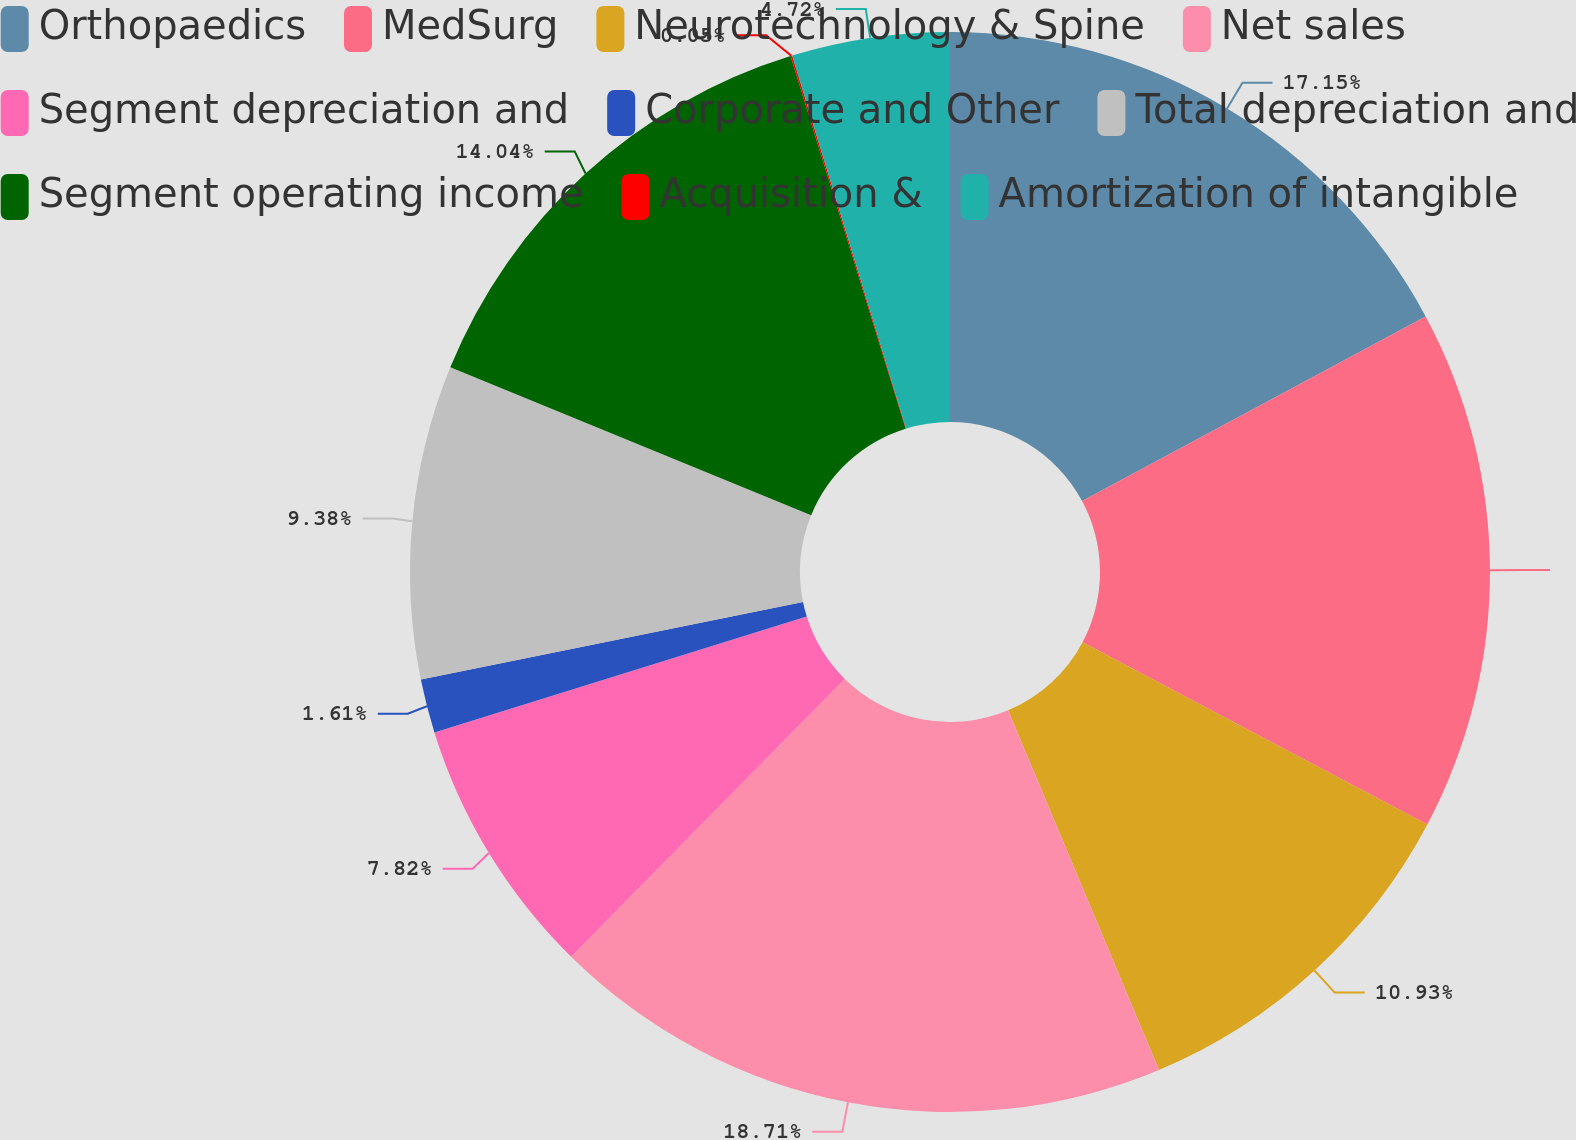Convert chart. <chart><loc_0><loc_0><loc_500><loc_500><pie_chart><fcel>Orthopaedics<fcel>MedSurg<fcel>Neurotechnology & Spine<fcel>Net sales<fcel>Segment depreciation and<fcel>Corporate and Other<fcel>Total depreciation and<fcel>Segment operating income<fcel>Acquisition &<fcel>Amortization of intangible<nl><fcel>17.15%<fcel>15.59%<fcel>10.93%<fcel>18.7%<fcel>7.82%<fcel>1.61%<fcel>9.38%<fcel>14.04%<fcel>0.05%<fcel>4.72%<nl></chart> 